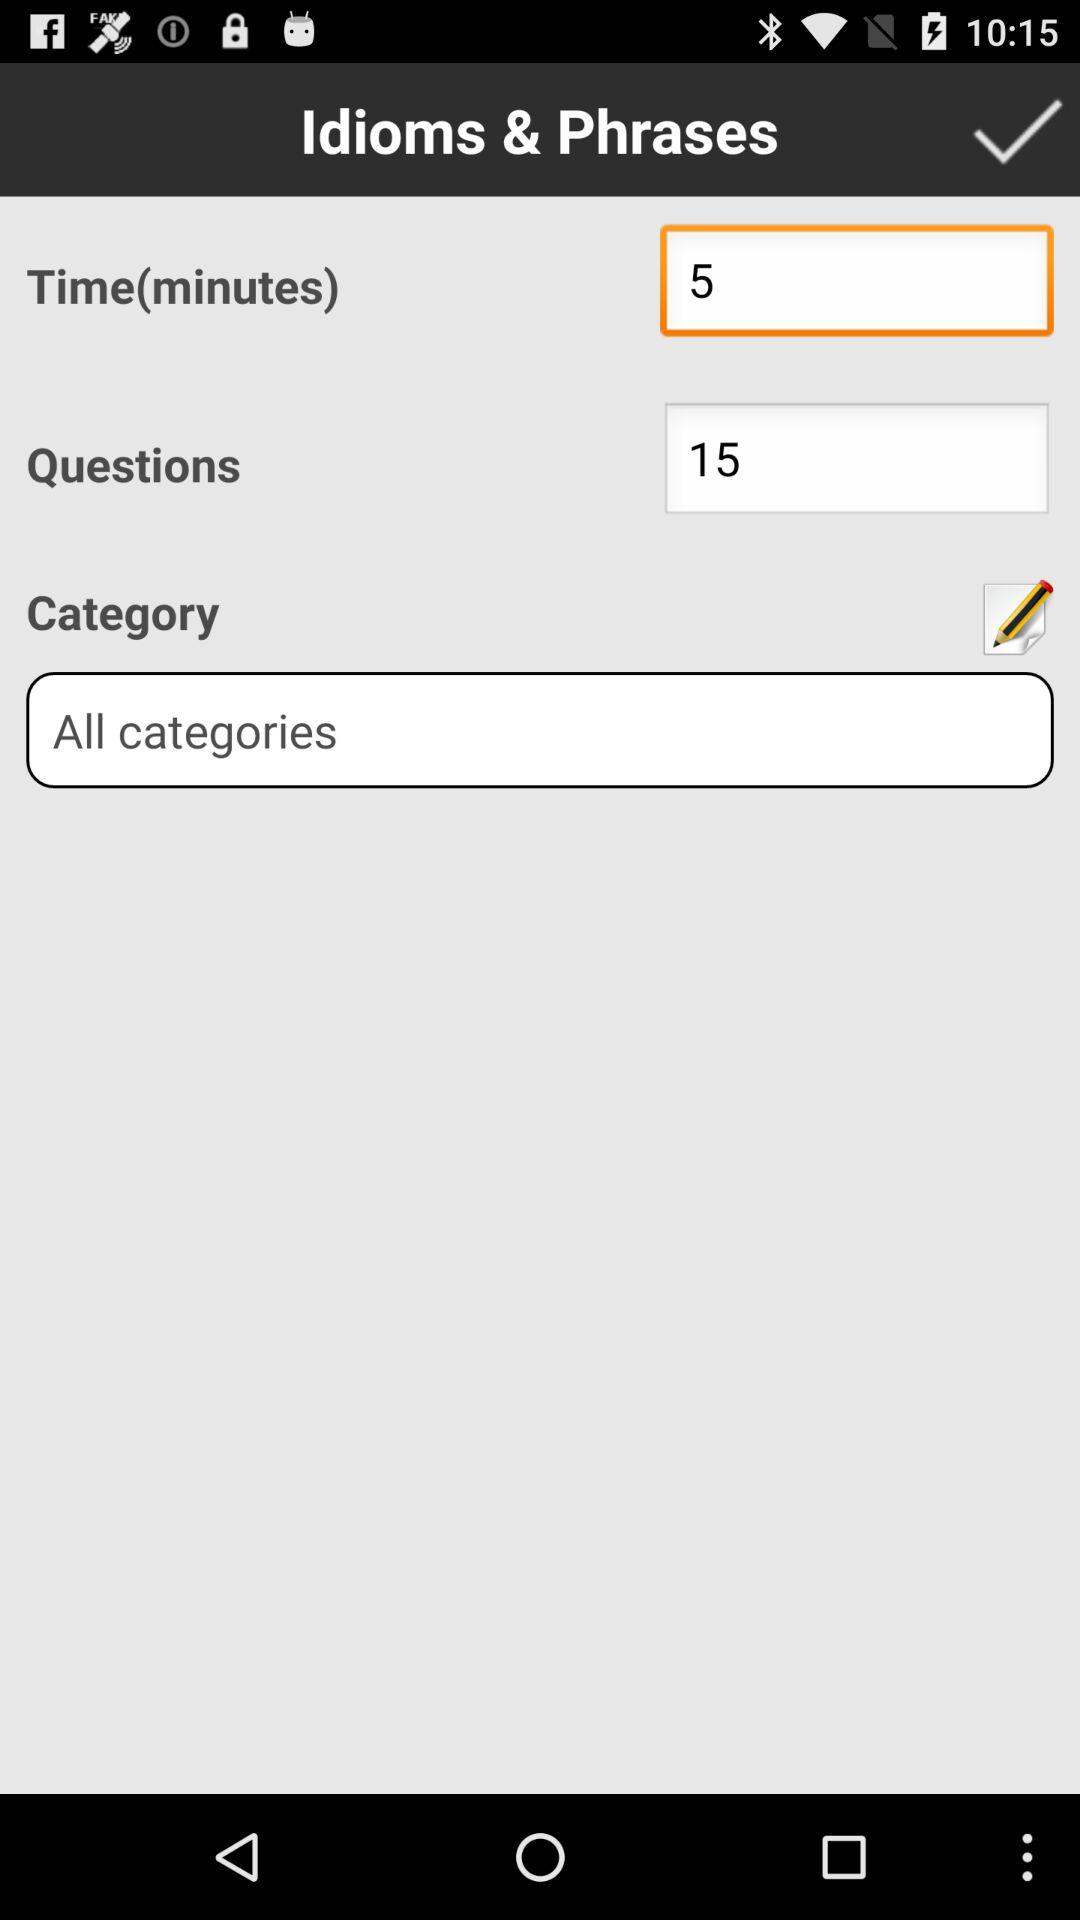How many questions are there? There are 15 questions. 